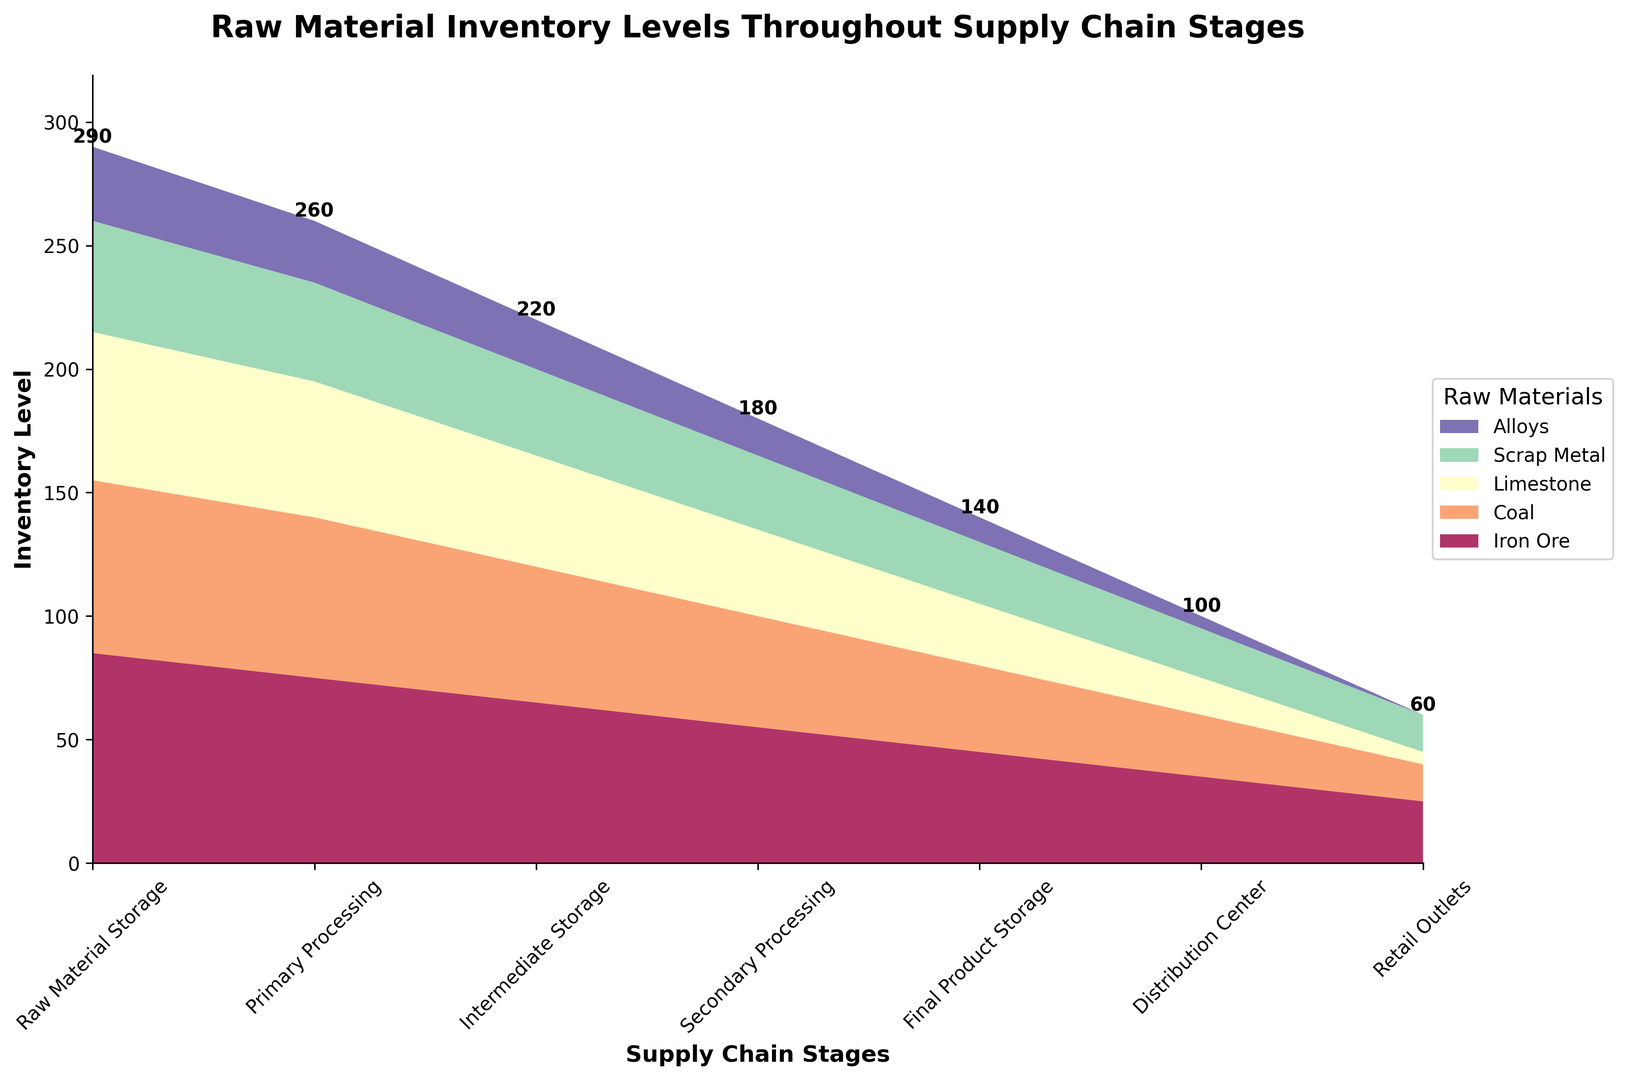What's the total inventory level of Iron Ore at the Primary Processing stage? Sum the inventory levels of Iron Ore at the Primary Processing stage. The data for this stage is Iron Ore = 75. So the total inventory level is 75.
Answer: 75 Which raw material has the lowest inventory level at the Retail Outlets stage? Compare the inventory levels of all raw materials at the Retail Outlets stage. The values are Iron Ore = 25, Coal = 15, Limestone = 5, Scrap Metal = 15, Alloys = 0. The lowest value is 0 for Alloys.
Answer: Alloys At which stage does the combined inventory of Coal and Limestone equal 90 units? Examine the inventory levels of Coal and Limestone at each stage and sum them. The relevant sums are: 
Raw Material Storage: 70 + 60 = 130
Primary Processing: 65 + 55 = 120
Intermediate Storage: 55 + 45 = 100
Secondary Processing: 45 + 35 = 80
Final Product Storage: 35 + 25 = 60
Distribution Center: 25 + 15 = 40
Retail Outlets: 15 + 5 = 20
None match 90 units exactly. So, none.
Answer: None Is the inventory level of Scrap Metal constant between any stages? Compare the inventory level of Scrap Metal across all stages. Check for any pairs of consecutive stages with the same value. The values are 45, 40, 35, 30, 25, 20, 15. There are no consecutive stages with the same value.
Answer: No How does the inventory of Iron Ore change from the Final Product Storage to the Distribution Center? Calculate the difference in inventory of Iron Ore between the Final Product Storage (45) and Distribution Center (35). The change is 45 - 35 = 10.
Answer: 10 units decrease Which raw material shows a continuous decrease in inventory levels across all stages? Examine the inventory levels of each raw material across all stages and check if they decrease continuously. 
Iron Ore: 85, 75, 65, 55, 45, 35, 25 (continuous decrease)
Coal: 70, 65, 55, 45, 35, 25, 15 (continuous decrease)
Limestone: 60, 55, 45, 35, 25, 15, 5 (continuous decrease)
Scrap Metal: 45, 40, 35, 30, 25, 20, 15 (continuous decrease)
Alloys: 30, 25, 20, 15, 10, 5, 0 (continuous decrease) 
All raw materials show a continuous decrease.
Answer: All raw materials What is the total inventory level at the Intermediate Storage stage for all raw materials? Sum the inventory levels of all raw materials at the Intermediate Storage stage. Iron Ore = 65, Coal = 55, Limestone = 45, Scrap Metal = 35, Alloys = 20. Total = 65 + 55 + 45 + 35 + 20 = 220.
Answer: 220 